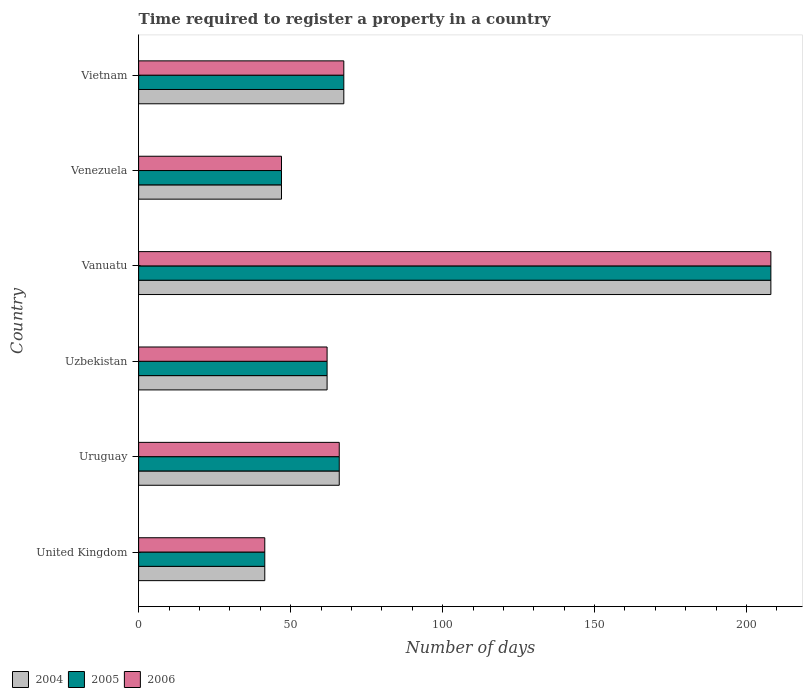How many groups of bars are there?
Offer a very short reply. 6. Are the number of bars on each tick of the Y-axis equal?
Offer a very short reply. Yes. How many bars are there on the 4th tick from the top?
Keep it short and to the point. 3. How many bars are there on the 2nd tick from the bottom?
Make the answer very short. 3. What is the label of the 5th group of bars from the top?
Your answer should be compact. Uruguay. What is the number of days required to register a property in 2005 in Vanuatu?
Ensure brevity in your answer.  208. Across all countries, what is the maximum number of days required to register a property in 2005?
Provide a short and direct response. 208. Across all countries, what is the minimum number of days required to register a property in 2006?
Your answer should be compact. 41.5. In which country was the number of days required to register a property in 2005 maximum?
Provide a succinct answer. Vanuatu. In which country was the number of days required to register a property in 2006 minimum?
Give a very brief answer. United Kingdom. What is the total number of days required to register a property in 2004 in the graph?
Give a very brief answer. 492. What is the difference between the number of days required to register a property in 2005 in Uzbekistan and that in Vanuatu?
Offer a very short reply. -146. What is the average number of days required to register a property in 2005 per country?
Give a very brief answer. 82. What is the difference between the number of days required to register a property in 2006 and number of days required to register a property in 2005 in Uzbekistan?
Ensure brevity in your answer.  0. What is the ratio of the number of days required to register a property in 2006 in Uzbekistan to that in Vanuatu?
Ensure brevity in your answer.  0.3. Is the number of days required to register a property in 2005 in United Kingdom less than that in Vanuatu?
Your answer should be very brief. Yes. What is the difference between the highest and the second highest number of days required to register a property in 2006?
Provide a short and direct response. 140.5. What is the difference between the highest and the lowest number of days required to register a property in 2006?
Give a very brief answer. 166.5. In how many countries, is the number of days required to register a property in 2004 greater than the average number of days required to register a property in 2004 taken over all countries?
Your response must be concise. 1. Is the sum of the number of days required to register a property in 2006 in Uzbekistan and Vietnam greater than the maximum number of days required to register a property in 2004 across all countries?
Keep it short and to the point. No. What does the 3rd bar from the top in Uruguay represents?
Provide a short and direct response. 2004. Is it the case that in every country, the sum of the number of days required to register a property in 2004 and number of days required to register a property in 2005 is greater than the number of days required to register a property in 2006?
Your answer should be very brief. Yes. How many bars are there?
Provide a short and direct response. 18. Where does the legend appear in the graph?
Keep it short and to the point. Bottom left. How many legend labels are there?
Keep it short and to the point. 3. What is the title of the graph?
Provide a succinct answer. Time required to register a property in a country. What is the label or title of the X-axis?
Ensure brevity in your answer.  Number of days. What is the label or title of the Y-axis?
Make the answer very short. Country. What is the Number of days in 2004 in United Kingdom?
Make the answer very short. 41.5. What is the Number of days in 2005 in United Kingdom?
Ensure brevity in your answer.  41.5. What is the Number of days of 2006 in United Kingdom?
Your answer should be compact. 41.5. What is the Number of days of 2004 in Uruguay?
Offer a very short reply. 66. What is the Number of days of 2005 in Uruguay?
Your response must be concise. 66. What is the Number of days of 2004 in Vanuatu?
Ensure brevity in your answer.  208. What is the Number of days of 2005 in Vanuatu?
Your answer should be compact. 208. What is the Number of days in 2006 in Vanuatu?
Make the answer very short. 208. What is the Number of days in 2004 in Vietnam?
Keep it short and to the point. 67.5. What is the Number of days in 2005 in Vietnam?
Your answer should be very brief. 67.5. What is the Number of days of 2006 in Vietnam?
Your answer should be compact. 67.5. Across all countries, what is the maximum Number of days of 2004?
Provide a succinct answer. 208. Across all countries, what is the maximum Number of days of 2005?
Offer a terse response. 208. Across all countries, what is the maximum Number of days in 2006?
Offer a terse response. 208. Across all countries, what is the minimum Number of days in 2004?
Provide a succinct answer. 41.5. Across all countries, what is the minimum Number of days of 2005?
Provide a succinct answer. 41.5. Across all countries, what is the minimum Number of days of 2006?
Your answer should be very brief. 41.5. What is the total Number of days of 2004 in the graph?
Give a very brief answer. 492. What is the total Number of days in 2005 in the graph?
Ensure brevity in your answer.  492. What is the total Number of days of 2006 in the graph?
Ensure brevity in your answer.  492. What is the difference between the Number of days in 2004 in United Kingdom and that in Uruguay?
Offer a very short reply. -24.5. What is the difference between the Number of days of 2005 in United Kingdom and that in Uruguay?
Offer a terse response. -24.5. What is the difference between the Number of days in 2006 in United Kingdom and that in Uruguay?
Your response must be concise. -24.5. What is the difference between the Number of days in 2004 in United Kingdom and that in Uzbekistan?
Your response must be concise. -20.5. What is the difference between the Number of days in 2005 in United Kingdom and that in Uzbekistan?
Your answer should be very brief. -20.5. What is the difference between the Number of days in 2006 in United Kingdom and that in Uzbekistan?
Ensure brevity in your answer.  -20.5. What is the difference between the Number of days in 2004 in United Kingdom and that in Vanuatu?
Your response must be concise. -166.5. What is the difference between the Number of days of 2005 in United Kingdom and that in Vanuatu?
Your answer should be compact. -166.5. What is the difference between the Number of days of 2006 in United Kingdom and that in Vanuatu?
Offer a very short reply. -166.5. What is the difference between the Number of days in 2004 in United Kingdom and that in Venezuela?
Offer a terse response. -5.5. What is the difference between the Number of days in 2005 in United Kingdom and that in Venezuela?
Your response must be concise. -5.5. What is the difference between the Number of days in 2005 in Uruguay and that in Uzbekistan?
Ensure brevity in your answer.  4. What is the difference between the Number of days of 2004 in Uruguay and that in Vanuatu?
Keep it short and to the point. -142. What is the difference between the Number of days in 2005 in Uruguay and that in Vanuatu?
Give a very brief answer. -142. What is the difference between the Number of days of 2006 in Uruguay and that in Vanuatu?
Your answer should be very brief. -142. What is the difference between the Number of days in 2006 in Uruguay and that in Venezuela?
Give a very brief answer. 19. What is the difference between the Number of days in 2005 in Uruguay and that in Vietnam?
Offer a very short reply. -1.5. What is the difference between the Number of days in 2006 in Uruguay and that in Vietnam?
Offer a very short reply. -1.5. What is the difference between the Number of days of 2004 in Uzbekistan and that in Vanuatu?
Your response must be concise. -146. What is the difference between the Number of days of 2005 in Uzbekistan and that in Vanuatu?
Your answer should be very brief. -146. What is the difference between the Number of days in 2006 in Uzbekistan and that in Vanuatu?
Offer a terse response. -146. What is the difference between the Number of days of 2006 in Uzbekistan and that in Venezuela?
Ensure brevity in your answer.  15. What is the difference between the Number of days in 2004 in Uzbekistan and that in Vietnam?
Provide a short and direct response. -5.5. What is the difference between the Number of days of 2006 in Uzbekistan and that in Vietnam?
Provide a succinct answer. -5.5. What is the difference between the Number of days in 2004 in Vanuatu and that in Venezuela?
Give a very brief answer. 161. What is the difference between the Number of days in 2005 in Vanuatu and that in Venezuela?
Offer a very short reply. 161. What is the difference between the Number of days in 2006 in Vanuatu and that in Venezuela?
Your response must be concise. 161. What is the difference between the Number of days in 2004 in Vanuatu and that in Vietnam?
Keep it short and to the point. 140.5. What is the difference between the Number of days in 2005 in Vanuatu and that in Vietnam?
Your answer should be very brief. 140.5. What is the difference between the Number of days in 2006 in Vanuatu and that in Vietnam?
Offer a very short reply. 140.5. What is the difference between the Number of days of 2004 in Venezuela and that in Vietnam?
Give a very brief answer. -20.5. What is the difference between the Number of days of 2005 in Venezuela and that in Vietnam?
Provide a succinct answer. -20.5. What is the difference between the Number of days in 2006 in Venezuela and that in Vietnam?
Offer a very short reply. -20.5. What is the difference between the Number of days of 2004 in United Kingdom and the Number of days of 2005 in Uruguay?
Offer a terse response. -24.5. What is the difference between the Number of days of 2004 in United Kingdom and the Number of days of 2006 in Uruguay?
Provide a succinct answer. -24.5. What is the difference between the Number of days of 2005 in United Kingdom and the Number of days of 2006 in Uruguay?
Provide a succinct answer. -24.5. What is the difference between the Number of days in 2004 in United Kingdom and the Number of days in 2005 in Uzbekistan?
Keep it short and to the point. -20.5. What is the difference between the Number of days of 2004 in United Kingdom and the Number of days of 2006 in Uzbekistan?
Make the answer very short. -20.5. What is the difference between the Number of days of 2005 in United Kingdom and the Number of days of 2006 in Uzbekistan?
Provide a short and direct response. -20.5. What is the difference between the Number of days in 2004 in United Kingdom and the Number of days in 2005 in Vanuatu?
Your answer should be very brief. -166.5. What is the difference between the Number of days in 2004 in United Kingdom and the Number of days in 2006 in Vanuatu?
Give a very brief answer. -166.5. What is the difference between the Number of days in 2005 in United Kingdom and the Number of days in 2006 in Vanuatu?
Make the answer very short. -166.5. What is the difference between the Number of days of 2004 in United Kingdom and the Number of days of 2005 in Venezuela?
Your response must be concise. -5.5. What is the difference between the Number of days in 2004 in United Kingdom and the Number of days in 2006 in Venezuela?
Provide a short and direct response. -5.5. What is the difference between the Number of days of 2005 in United Kingdom and the Number of days of 2006 in Venezuela?
Offer a terse response. -5.5. What is the difference between the Number of days in 2005 in United Kingdom and the Number of days in 2006 in Vietnam?
Keep it short and to the point. -26. What is the difference between the Number of days in 2004 in Uruguay and the Number of days in 2005 in Uzbekistan?
Your answer should be very brief. 4. What is the difference between the Number of days in 2005 in Uruguay and the Number of days in 2006 in Uzbekistan?
Keep it short and to the point. 4. What is the difference between the Number of days in 2004 in Uruguay and the Number of days in 2005 in Vanuatu?
Give a very brief answer. -142. What is the difference between the Number of days of 2004 in Uruguay and the Number of days of 2006 in Vanuatu?
Ensure brevity in your answer.  -142. What is the difference between the Number of days of 2005 in Uruguay and the Number of days of 2006 in Vanuatu?
Ensure brevity in your answer.  -142. What is the difference between the Number of days of 2004 in Uruguay and the Number of days of 2005 in Venezuela?
Offer a very short reply. 19. What is the difference between the Number of days of 2004 in Uruguay and the Number of days of 2006 in Venezuela?
Your answer should be compact. 19. What is the difference between the Number of days in 2005 in Uruguay and the Number of days in 2006 in Vietnam?
Give a very brief answer. -1.5. What is the difference between the Number of days in 2004 in Uzbekistan and the Number of days in 2005 in Vanuatu?
Provide a short and direct response. -146. What is the difference between the Number of days in 2004 in Uzbekistan and the Number of days in 2006 in Vanuatu?
Offer a terse response. -146. What is the difference between the Number of days of 2005 in Uzbekistan and the Number of days of 2006 in Vanuatu?
Offer a very short reply. -146. What is the difference between the Number of days of 2005 in Uzbekistan and the Number of days of 2006 in Venezuela?
Ensure brevity in your answer.  15. What is the difference between the Number of days of 2004 in Uzbekistan and the Number of days of 2005 in Vietnam?
Your answer should be very brief. -5.5. What is the difference between the Number of days of 2004 in Uzbekistan and the Number of days of 2006 in Vietnam?
Provide a succinct answer. -5.5. What is the difference between the Number of days of 2005 in Uzbekistan and the Number of days of 2006 in Vietnam?
Give a very brief answer. -5.5. What is the difference between the Number of days of 2004 in Vanuatu and the Number of days of 2005 in Venezuela?
Make the answer very short. 161. What is the difference between the Number of days in 2004 in Vanuatu and the Number of days in 2006 in Venezuela?
Offer a terse response. 161. What is the difference between the Number of days in 2005 in Vanuatu and the Number of days in 2006 in Venezuela?
Ensure brevity in your answer.  161. What is the difference between the Number of days in 2004 in Vanuatu and the Number of days in 2005 in Vietnam?
Provide a short and direct response. 140.5. What is the difference between the Number of days in 2004 in Vanuatu and the Number of days in 2006 in Vietnam?
Give a very brief answer. 140.5. What is the difference between the Number of days of 2005 in Vanuatu and the Number of days of 2006 in Vietnam?
Keep it short and to the point. 140.5. What is the difference between the Number of days of 2004 in Venezuela and the Number of days of 2005 in Vietnam?
Ensure brevity in your answer.  -20.5. What is the difference between the Number of days of 2004 in Venezuela and the Number of days of 2006 in Vietnam?
Your response must be concise. -20.5. What is the difference between the Number of days in 2005 in Venezuela and the Number of days in 2006 in Vietnam?
Your answer should be compact. -20.5. What is the average Number of days in 2005 per country?
Your answer should be compact. 82. What is the difference between the Number of days in 2004 and Number of days in 2005 in United Kingdom?
Your answer should be very brief. 0. What is the difference between the Number of days of 2004 and Number of days of 2006 in United Kingdom?
Your answer should be compact. 0. What is the difference between the Number of days in 2005 and Number of days in 2006 in United Kingdom?
Provide a succinct answer. 0. What is the difference between the Number of days of 2004 and Number of days of 2005 in Uruguay?
Provide a succinct answer. 0. What is the difference between the Number of days of 2005 and Number of days of 2006 in Uzbekistan?
Ensure brevity in your answer.  0. What is the difference between the Number of days in 2004 and Number of days in 2005 in Vanuatu?
Make the answer very short. 0. What is the difference between the Number of days of 2004 and Number of days of 2006 in Vanuatu?
Your answer should be compact. 0. What is the difference between the Number of days of 2005 and Number of days of 2006 in Vanuatu?
Your answer should be compact. 0. What is the difference between the Number of days of 2004 and Number of days of 2006 in Venezuela?
Your answer should be compact. 0. What is the difference between the Number of days in 2004 and Number of days in 2005 in Vietnam?
Offer a terse response. 0. What is the ratio of the Number of days of 2004 in United Kingdom to that in Uruguay?
Provide a short and direct response. 0.63. What is the ratio of the Number of days of 2005 in United Kingdom to that in Uruguay?
Give a very brief answer. 0.63. What is the ratio of the Number of days of 2006 in United Kingdom to that in Uruguay?
Your answer should be very brief. 0.63. What is the ratio of the Number of days of 2004 in United Kingdom to that in Uzbekistan?
Make the answer very short. 0.67. What is the ratio of the Number of days of 2005 in United Kingdom to that in Uzbekistan?
Provide a succinct answer. 0.67. What is the ratio of the Number of days of 2006 in United Kingdom to that in Uzbekistan?
Provide a short and direct response. 0.67. What is the ratio of the Number of days of 2004 in United Kingdom to that in Vanuatu?
Give a very brief answer. 0.2. What is the ratio of the Number of days of 2005 in United Kingdom to that in Vanuatu?
Your answer should be very brief. 0.2. What is the ratio of the Number of days in 2006 in United Kingdom to that in Vanuatu?
Provide a succinct answer. 0.2. What is the ratio of the Number of days of 2004 in United Kingdom to that in Venezuela?
Provide a short and direct response. 0.88. What is the ratio of the Number of days in 2005 in United Kingdom to that in Venezuela?
Provide a succinct answer. 0.88. What is the ratio of the Number of days of 2006 in United Kingdom to that in Venezuela?
Make the answer very short. 0.88. What is the ratio of the Number of days of 2004 in United Kingdom to that in Vietnam?
Provide a succinct answer. 0.61. What is the ratio of the Number of days in 2005 in United Kingdom to that in Vietnam?
Provide a succinct answer. 0.61. What is the ratio of the Number of days in 2006 in United Kingdom to that in Vietnam?
Your answer should be compact. 0.61. What is the ratio of the Number of days in 2004 in Uruguay to that in Uzbekistan?
Keep it short and to the point. 1.06. What is the ratio of the Number of days in 2005 in Uruguay to that in Uzbekistan?
Give a very brief answer. 1.06. What is the ratio of the Number of days in 2006 in Uruguay to that in Uzbekistan?
Your answer should be compact. 1.06. What is the ratio of the Number of days of 2004 in Uruguay to that in Vanuatu?
Your response must be concise. 0.32. What is the ratio of the Number of days of 2005 in Uruguay to that in Vanuatu?
Your response must be concise. 0.32. What is the ratio of the Number of days of 2006 in Uruguay to that in Vanuatu?
Offer a very short reply. 0.32. What is the ratio of the Number of days in 2004 in Uruguay to that in Venezuela?
Keep it short and to the point. 1.4. What is the ratio of the Number of days of 2005 in Uruguay to that in Venezuela?
Ensure brevity in your answer.  1.4. What is the ratio of the Number of days of 2006 in Uruguay to that in Venezuela?
Provide a succinct answer. 1.4. What is the ratio of the Number of days of 2004 in Uruguay to that in Vietnam?
Make the answer very short. 0.98. What is the ratio of the Number of days of 2005 in Uruguay to that in Vietnam?
Give a very brief answer. 0.98. What is the ratio of the Number of days of 2006 in Uruguay to that in Vietnam?
Make the answer very short. 0.98. What is the ratio of the Number of days of 2004 in Uzbekistan to that in Vanuatu?
Offer a terse response. 0.3. What is the ratio of the Number of days in 2005 in Uzbekistan to that in Vanuatu?
Your answer should be very brief. 0.3. What is the ratio of the Number of days in 2006 in Uzbekistan to that in Vanuatu?
Provide a short and direct response. 0.3. What is the ratio of the Number of days of 2004 in Uzbekistan to that in Venezuela?
Offer a terse response. 1.32. What is the ratio of the Number of days of 2005 in Uzbekistan to that in Venezuela?
Your response must be concise. 1.32. What is the ratio of the Number of days of 2006 in Uzbekistan to that in Venezuela?
Ensure brevity in your answer.  1.32. What is the ratio of the Number of days in 2004 in Uzbekistan to that in Vietnam?
Your answer should be very brief. 0.92. What is the ratio of the Number of days of 2005 in Uzbekistan to that in Vietnam?
Keep it short and to the point. 0.92. What is the ratio of the Number of days of 2006 in Uzbekistan to that in Vietnam?
Offer a very short reply. 0.92. What is the ratio of the Number of days in 2004 in Vanuatu to that in Venezuela?
Your response must be concise. 4.43. What is the ratio of the Number of days of 2005 in Vanuatu to that in Venezuela?
Keep it short and to the point. 4.43. What is the ratio of the Number of days of 2006 in Vanuatu to that in Venezuela?
Ensure brevity in your answer.  4.43. What is the ratio of the Number of days in 2004 in Vanuatu to that in Vietnam?
Provide a short and direct response. 3.08. What is the ratio of the Number of days of 2005 in Vanuatu to that in Vietnam?
Your answer should be very brief. 3.08. What is the ratio of the Number of days of 2006 in Vanuatu to that in Vietnam?
Ensure brevity in your answer.  3.08. What is the ratio of the Number of days in 2004 in Venezuela to that in Vietnam?
Offer a very short reply. 0.7. What is the ratio of the Number of days in 2005 in Venezuela to that in Vietnam?
Give a very brief answer. 0.7. What is the ratio of the Number of days of 2006 in Venezuela to that in Vietnam?
Offer a terse response. 0.7. What is the difference between the highest and the second highest Number of days of 2004?
Ensure brevity in your answer.  140.5. What is the difference between the highest and the second highest Number of days in 2005?
Provide a short and direct response. 140.5. What is the difference between the highest and the second highest Number of days of 2006?
Provide a succinct answer. 140.5. What is the difference between the highest and the lowest Number of days in 2004?
Your response must be concise. 166.5. What is the difference between the highest and the lowest Number of days of 2005?
Provide a short and direct response. 166.5. What is the difference between the highest and the lowest Number of days of 2006?
Keep it short and to the point. 166.5. 